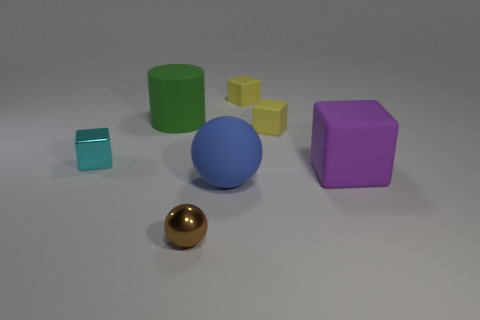Do the purple object and the shiny thing that is behind the matte ball have the same shape? Yes, both the purple object and the shiny golden object have a spherical shape, indicating they are both balls. The purple one has a matte finish, whereas the shiny golden one has a glossy finish which reflects light, giving it a distinct shine. 